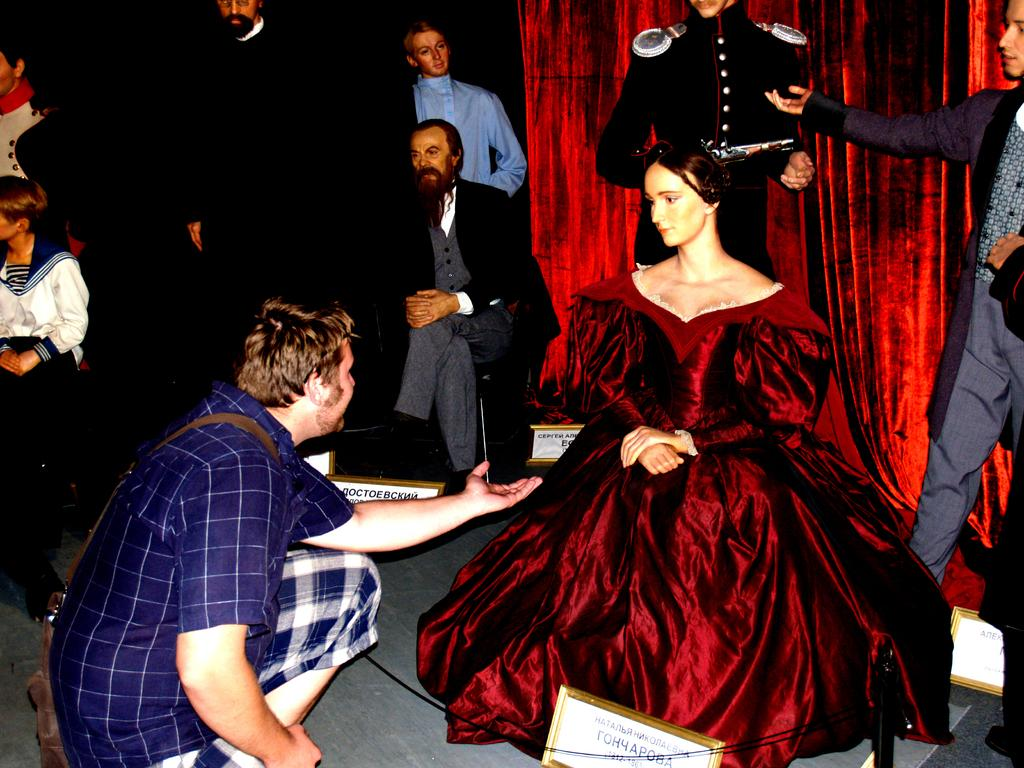What can be seen in the image besides the woman and the man? There are statues in the image. What is the woman wearing in the image? The woman is wearing a maroon color dress. What is the man doing in the image? The man is sitting in front of the woman. What is present in the background of the image? There is a curtain in the background of the image. What type of star can be seen on the woman's scarf in the image? There is no scarf present in the image, and therefore no star can be seen on it. 